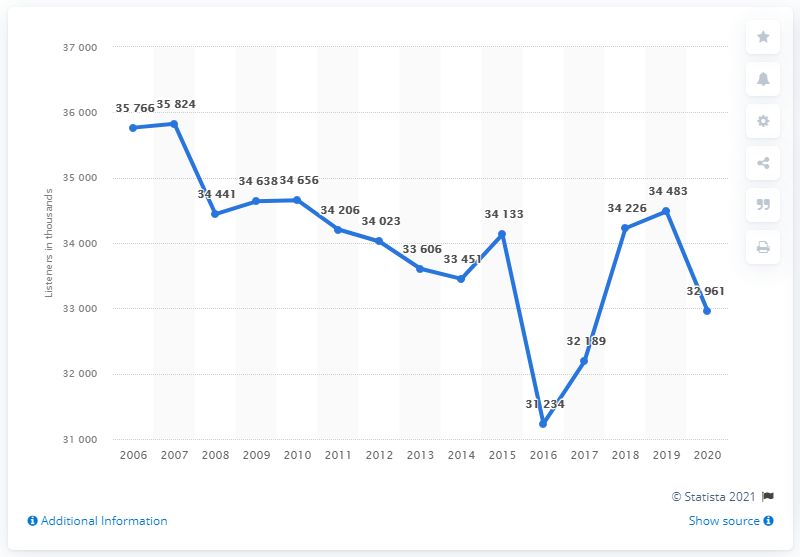Draw attention to some important aspects in this diagram. In 2020, the number of radio listeners in Italy was 32,961. In 2019, there were 3,422 people who listened. In Italy, it is estimated that 34,226 people listen to radio. 